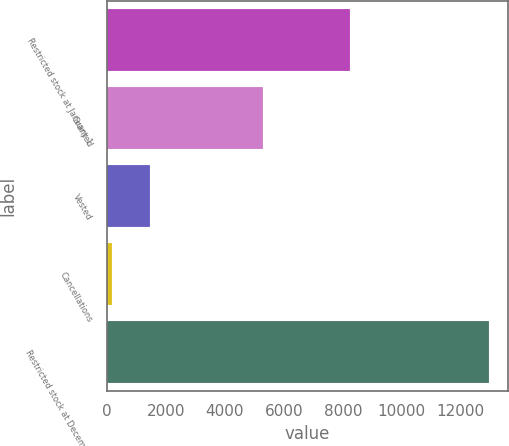Convert chart. <chart><loc_0><loc_0><loc_500><loc_500><bar_chart><fcel>Restricted stock at January 1<fcel>Granted<fcel>Vested<fcel>Cancellations<fcel>Restricted stock at December<nl><fcel>8256<fcel>5301<fcel>1465.6<fcel>188<fcel>12964<nl></chart> 